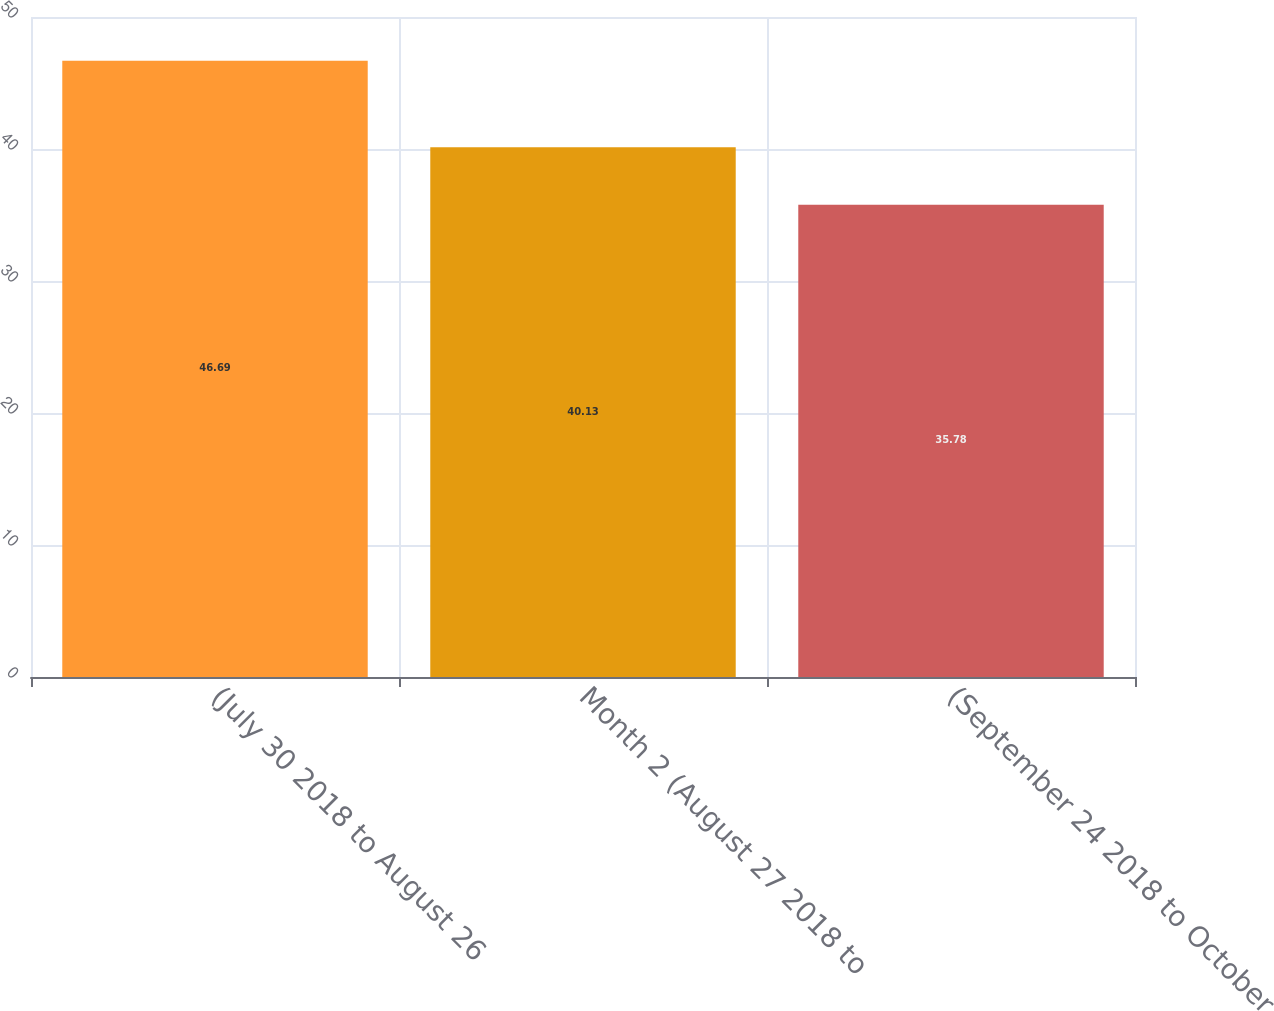<chart> <loc_0><loc_0><loc_500><loc_500><bar_chart><fcel>(July 30 2018 to August 26<fcel>Month 2 (August 27 2018 to<fcel>(September 24 2018 to October<nl><fcel>46.69<fcel>40.13<fcel>35.78<nl></chart> 